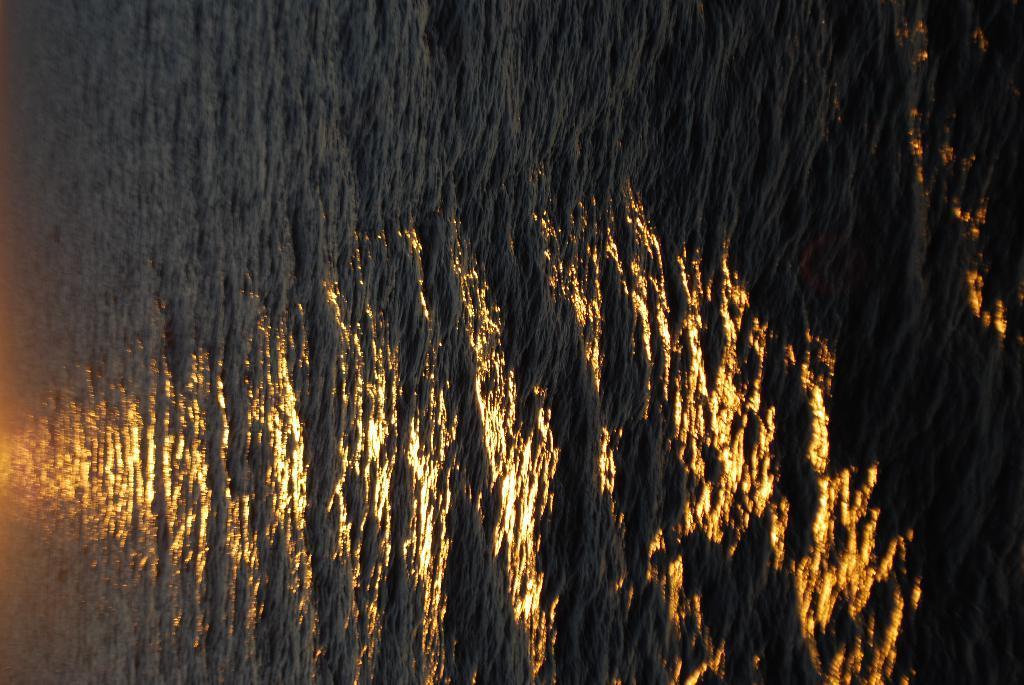Describe this image in one or two sentences. This image is taken outdoors. In this image there is a sea. 